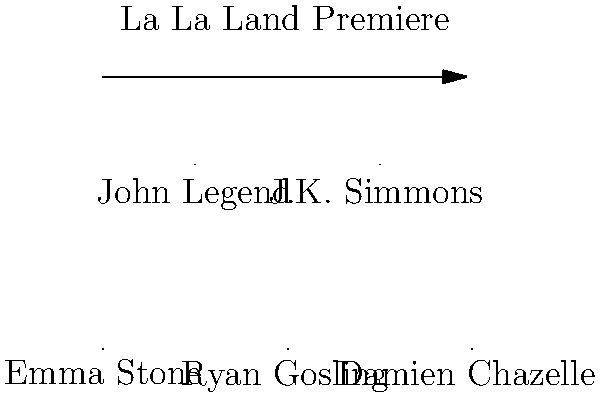In this heartwarming group photo from the "La La Land" movie premiere, which actor known for their charming smile and charismatic presence is standing next to the director, Damien Chazelle? Let's break this down step-by-step:

1. First, we need to identify Damien Chazelle, the director. He's labeled in the image on the far right.

2. Next, we look at who is standing next to Damien Chazelle. To his left (our right as we look at the image) is Ryan Gosling.

3. Ryan Gosling is indeed known for his charming smile and charismatic presence, which fits the description in the question.

4. It's worth noting that Emma Stone, Ryan's co-star in the film, is also in the photo but on the far left, not next to the director.

5. The other people in the photo are John Legend and J.K. Simmons, who had supporting roles in the film.

6. Given the persona of a casual, laid-back movie watcher who enjoys feel-good films, "La La Land" is a perfect fit as it's known for its uplifting and romantic story.

Therefore, the actor standing next to the director who fits the description is Ryan Gosling.
Answer: Ryan Gosling 